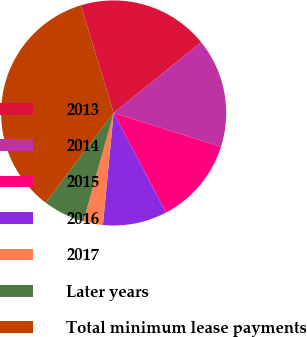Convert chart. <chart><loc_0><loc_0><loc_500><loc_500><pie_chart><fcel>2013<fcel>2014<fcel>2015<fcel>2016<fcel>2017<fcel>Later years<fcel>Total minimum lease payments<nl><fcel>18.88%<fcel>15.66%<fcel>12.45%<fcel>9.23%<fcel>2.8%<fcel>6.02%<fcel>34.96%<nl></chart> 